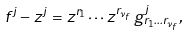Convert formula to latex. <formula><loc_0><loc_0><loc_500><loc_500>f ^ { j } - z ^ { j } = z ^ { r _ { 1 } } \cdots z ^ { r _ { \nu _ { f } } } \, g ^ { j } _ { r _ { 1 } \dots r _ { \nu _ { f } } } ,</formula> 